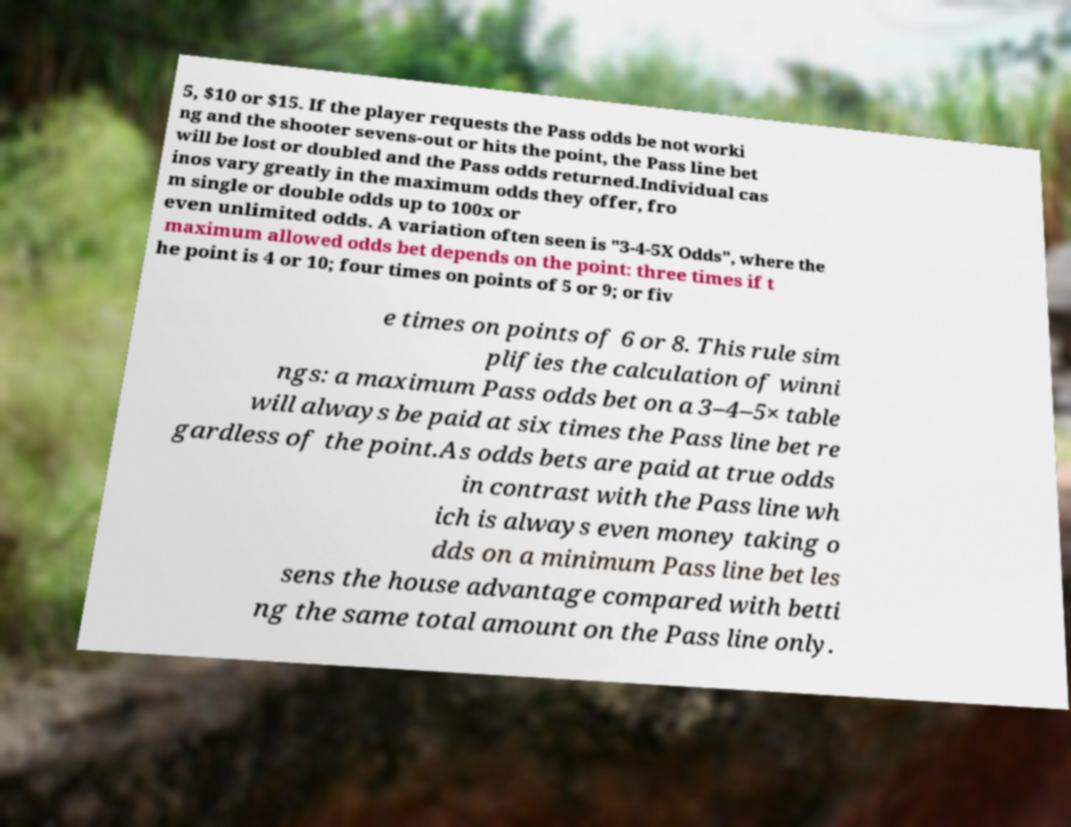I need the written content from this picture converted into text. Can you do that? 5, $10 or $15. If the player requests the Pass odds be not worki ng and the shooter sevens-out or hits the point, the Pass line bet will be lost or doubled and the Pass odds returned.Individual cas inos vary greatly in the maximum odds they offer, fro m single or double odds up to 100x or even unlimited odds. A variation often seen is "3-4-5X Odds", where the maximum allowed odds bet depends on the point: three times if t he point is 4 or 10; four times on points of 5 or 9; or fiv e times on points of 6 or 8. This rule sim plifies the calculation of winni ngs: a maximum Pass odds bet on a 3–4–5× table will always be paid at six times the Pass line bet re gardless of the point.As odds bets are paid at true odds in contrast with the Pass line wh ich is always even money taking o dds on a minimum Pass line bet les sens the house advantage compared with betti ng the same total amount on the Pass line only. 